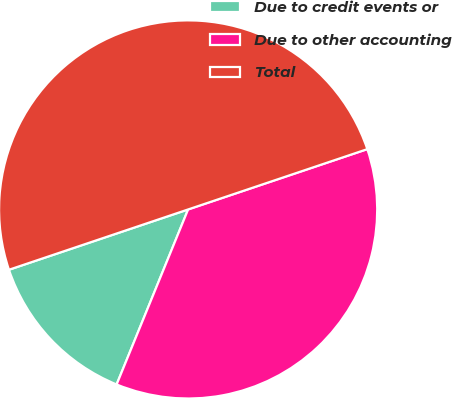Convert chart to OTSL. <chart><loc_0><loc_0><loc_500><loc_500><pie_chart><fcel>Due to credit events or<fcel>Due to other accounting<fcel>Total<nl><fcel>13.66%<fcel>36.34%<fcel>50.0%<nl></chart> 